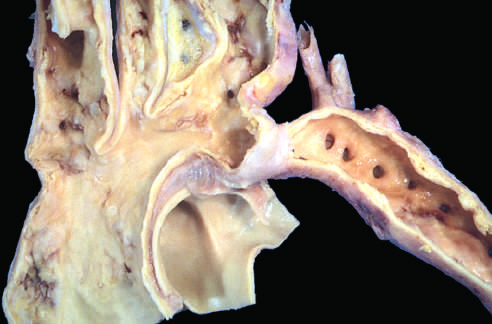re two helical spirochetes perfused predominantly by way of dilated, tortuous collateral channels?
Answer the question using a single word or phrase. No 